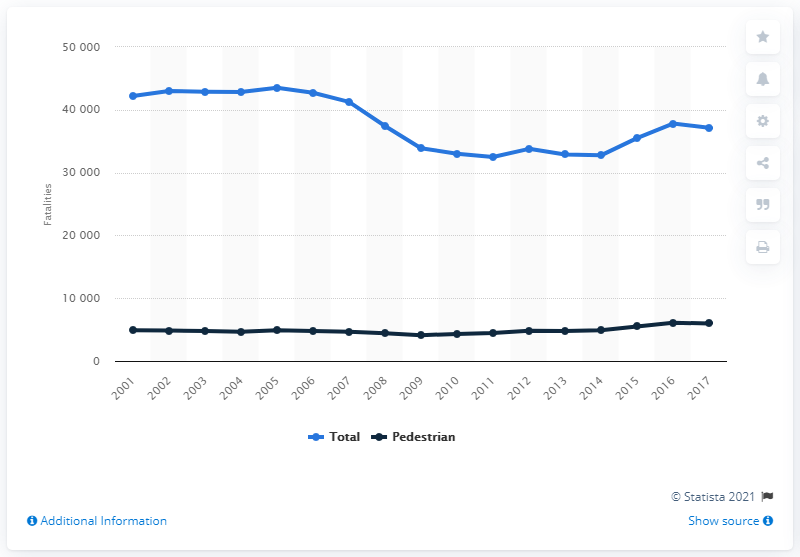List a handful of essential elements in this visual. The last time pedestrians died in traffic crashes in the United States was in 2001. 